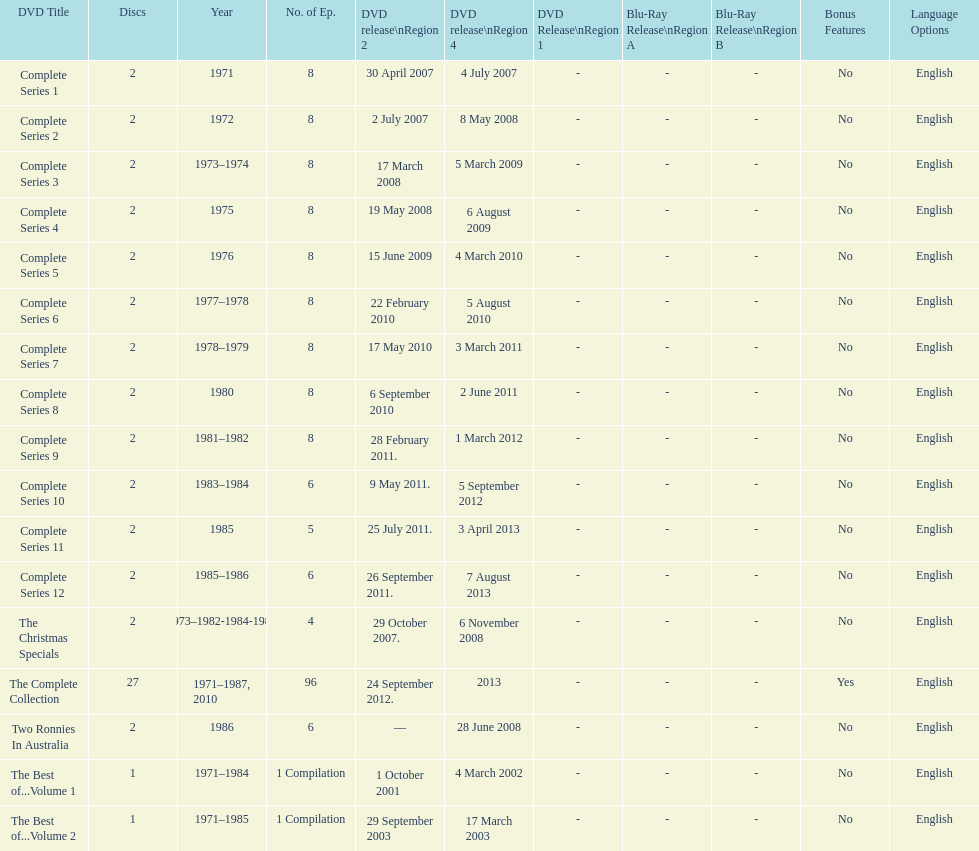What comes immediately after complete series 11? Complete Series 12. 